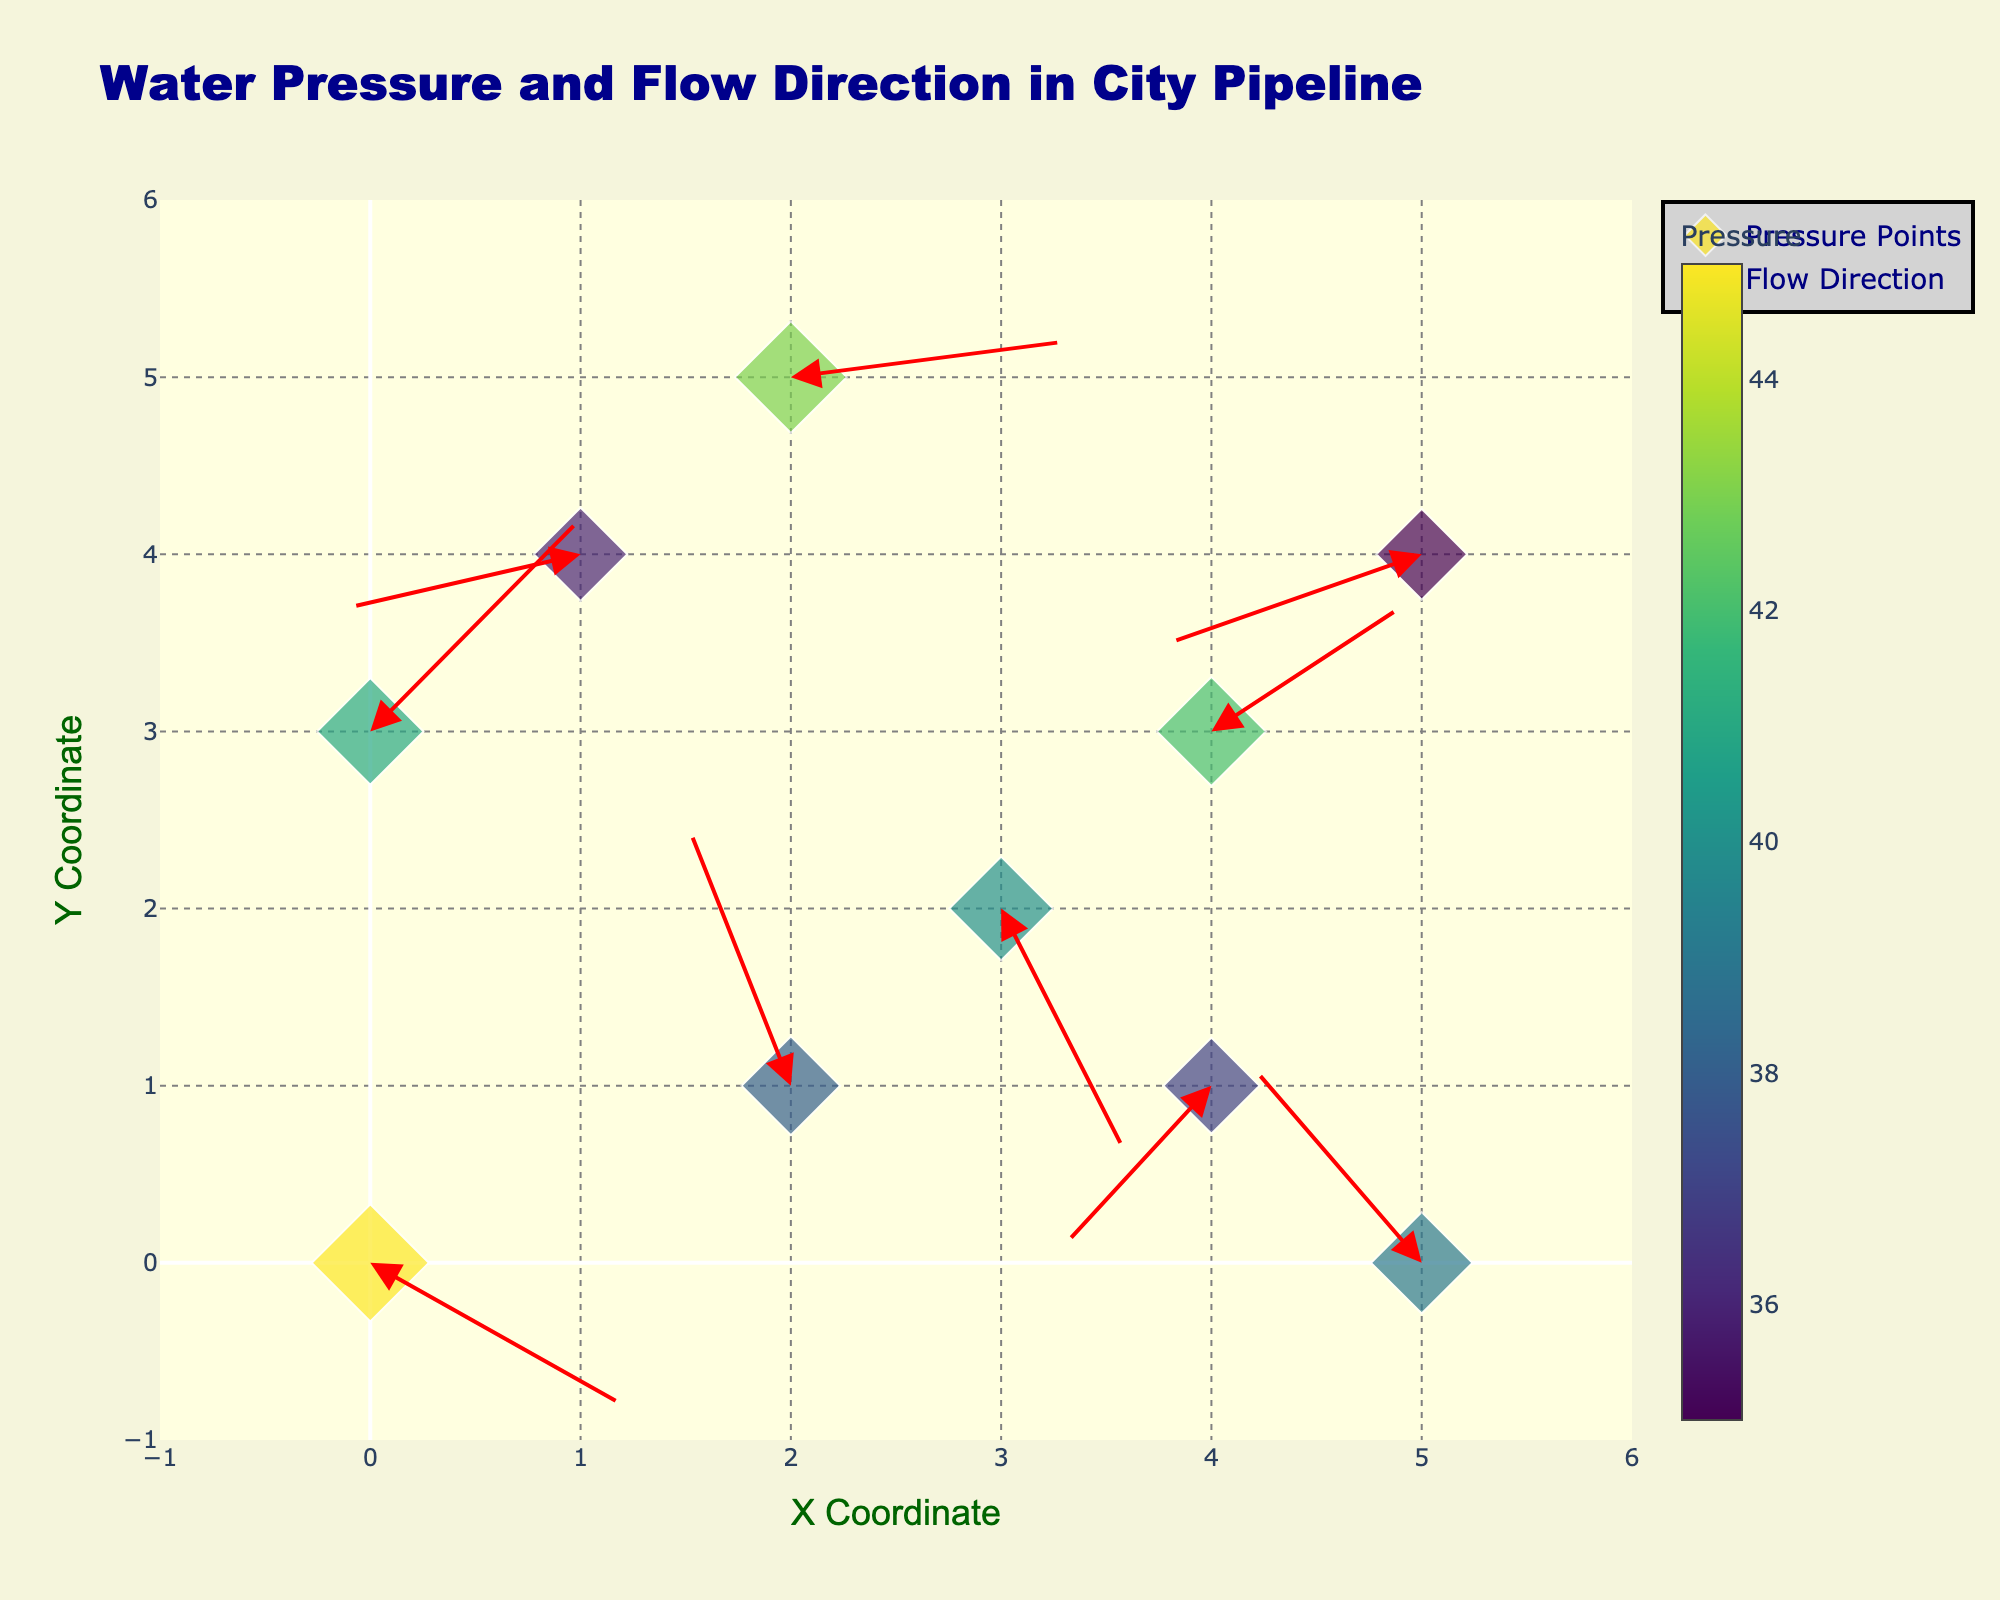what is the title of the quiver plot? The title is usually located at the top of the plot and often describes what is shown in the plot. In this case, the title is "Water Pressure and Flow Direction in City Pipeline".
Answer: Water Pressure and Flow Direction in City Pipeline How many data points are plotted in the figure? To determine the number of data points, we need to count the number of markers (diamonds) displayed in the plot. Based on the provided data, there are 10 data points.
Answer: 10 Which data point has the highest water pressure? To find this, we need to look at the color gradient on the markers and the size of the markers. The data point with the largest marker and the most intense color (as per Viridis color scale) corresponds to the highest pressure. According to the data, the highest pressure is 45 located at (0, 0).
Answer: (0, 0) What is the range of the x-axis and y-axis in the plot? The range of the axes can be checked by observing the axis labels or ticks. From the given update layout lines, the x-axis range is from -1 to 6, and the y-axis range is also from -1 to 6.
Answer: -1 to 6 Which data point has the largest flow direction arrow? The size of the flow direction arrow is determined by the vector components u and v. By looking at the data, point (2, 1) with u=-0.5 and v=1.5 has the largest arrow.
Answer: (2, 1) Is the flow direction arrow at point (4, 1) pointing upward or downward? To determine this, we observe the annotation arrow direction. For point (4, 1), vector components are u=-0.7 and v=-0.9. Since v is negative, the arrow points downward.
Answer: downward Which data point has the lowest water pressure, and what are its coordinates? By observing the smallest and least intense-colored marker, we can determine the lowest pressure. According to the data, the lowest pressure is 35 at coordinates (5, 4).
Answer: (5, 4) What are the x and y coordinates of the point where the flow direction is towards the right and has maximum water pressure? We need to look for a point where the flow component u is positive and the pressure is highest. The highest pressure is 45, located at (0, 0), and flow direction u=1.2 towards the right.
Answer: (0, 0) Which point has the shortest flow arrow, and what indicates this? The shortest arrow can be determined by the smallest magnitude of vector (u,v). Point (1, 4) with u=-1.1 and v=-0.3 has the smallest arrow as sqrt((-1.1)^2 + (-0.3)^2) is minimal among all.
Answer: (1, 4) What are the components of the flow direction arrow at the point with coordinates (2, 5)? We look at the related data point to get the vector components. For point (2, 5), the components are u=1.3 and v=0.2.
Answer: u=1.3, v=0.2 